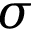Convert formula to latex. <formula><loc_0><loc_0><loc_500><loc_500>{ \sigma }</formula> 